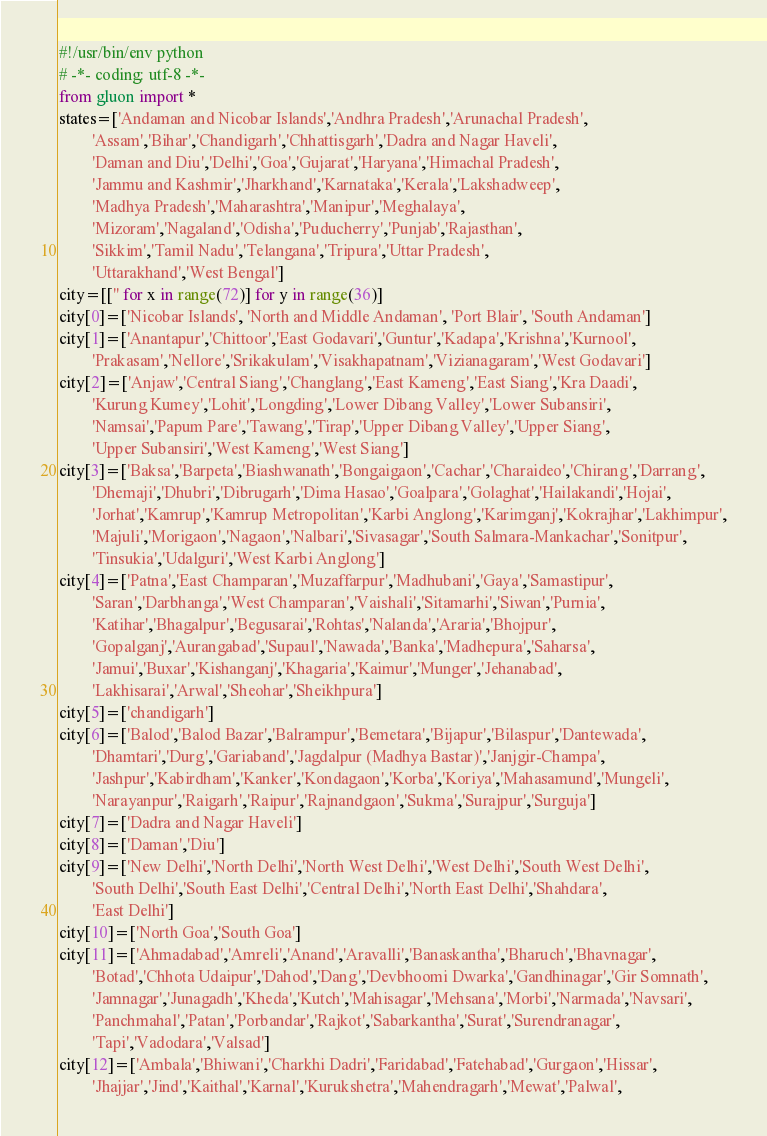<code> <loc_0><loc_0><loc_500><loc_500><_Python_>#!/usr/bin/env python
# -*- coding: utf-8 -*-
from gluon import *
states=['Andaman and Nicobar Islands','Andhra Pradesh','Arunachal Pradesh',
		'Assam','Bihar','Chandigarh','Chhattisgarh','Dadra and Nagar Haveli',
		'Daman and Diu','Delhi','Goa','Gujarat','Haryana','Himachal Pradesh',
		'Jammu and Kashmir','Jharkhand','Karnataka','Kerala','Lakshadweep',
		'Madhya Pradesh','Maharashtra','Manipur','Meghalaya',
		'Mizoram','Nagaland','Odisha','Puducherry','Punjab','Rajasthan',
		'Sikkim','Tamil Nadu','Telangana','Tripura','Uttar Pradesh',
		'Uttarakhand','West Bengal']
city=[['' for x in range(72)] for y in range(36)]
city[0]=['Nicobar Islands', 'North and Middle Andaman', 'Port Blair', 'South Andaman']
city[1]=['Anantapur','Chittoor','East Godavari','Guntur','Kadapa','Krishna','Kurnool',
		'Prakasam','Nellore','Srikakulam','Visakhapatnam','Vizianagaram','West Godavari']
city[2]=['Anjaw','Central Siang','Changlang','East Kameng','East Siang','Kra Daadi',
		'Kurung Kumey','Lohit','Longding','Lower Dibang Valley','Lower Subansiri',
		'Namsai','Papum Pare','Tawang','Tirap','Upper Dibang Valley','Upper Siang',
		'Upper Subansiri','West Kameng','West Siang']
city[3]=['Baksa','Barpeta','Biashwanath','Bongaigaon','Cachar','Charaideo','Chirang','Darrang',
		'Dhemaji','Dhubri','Dibrugarh','Dima Hasao','Goalpara','Golaghat','Hailakandi','Hojai',
		'Jorhat','Kamrup','Kamrup Metropolitan','Karbi Anglong','Karimganj','Kokrajhar','Lakhimpur',
		'Majuli','Morigaon','Nagaon','Nalbari','Sivasagar','South Salmara-Mankachar','Sonitpur',
		'Tinsukia','Udalguri','West Karbi Anglong']
city[4]=['Patna','East Champaran','Muzaffarpur','Madhubani','Gaya','Samastipur',
		'Saran','Darbhanga','West Champaran','Vaishali','Sitamarhi','Siwan','Purnia',
		'Katihar','Bhagalpur','Begusarai','Rohtas','Nalanda','Araria','Bhojpur',
		'Gopalganj','Aurangabad','Supaul','Nawada','Banka','Madhepura','Saharsa',
		'Jamui','Buxar','Kishanganj','Khagaria','Kaimur','Munger','Jehanabad',
		'Lakhisarai','Arwal','Sheohar','Sheikhpura']
city[5]=['chandigarh']
city[6]=['Balod','Balod Bazar','Balrampur','Bemetara','Bijapur','Bilaspur','Dantewada',
		'Dhamtari','Durg','Gariaband','Jagdalpur (Madhya Bastar)','Janjgir-Champa',
		'Jashpur','Kabirdham','Kanker','Kondagaon','Korba','Koriya','Mahasamund','Mungeli',
		'Narayanpur','Raigarh','Raipur','Rajnandgaon','Sukma','Surajpur','Surguja']
city[7]=['Dadra and Nagar Haveli']
city[8]=['Daman','Diu']
city[9]=['New Delhi','North Delhi','North West Delhi','West Delhi','South West Delhi',
		'South Delhi','South East Delhi','Central Delhi','North East Delhi','Shahdara',
		'East Delhi']
city[10]=['North Goa','South Goa']
city[11]=['Ahmadabad','Amreli','Anand','Aravalli','Banaskantha','Bharuch','Bhavnagar',
		'Botad','Chhota Udaipur','Dahod','Dang','Devbhoomi Dwarka','Gandhinagar','Gir Somnath',
		'Jamnagar','Junagadh','Kheda','Kutch','Mahisagar','Mehsana','Morbi','Narmada','Navsari',
		'Panchmahal','Patan','Porbandar','Rajkot','Sabarkantha','Surat','Surendranagar',
		'Tapi','Vadodara','Valsad']
city[12]=['Ambala','Bhiwani','Charkhi Dadri','Faridabad','Fatehabad','Gurgaon','Hissar',
		'Jhajjar','Jind','Kaithal','Karnal','Kurukshetra','Mahendragarh','Mewat','Palwal',</code> 